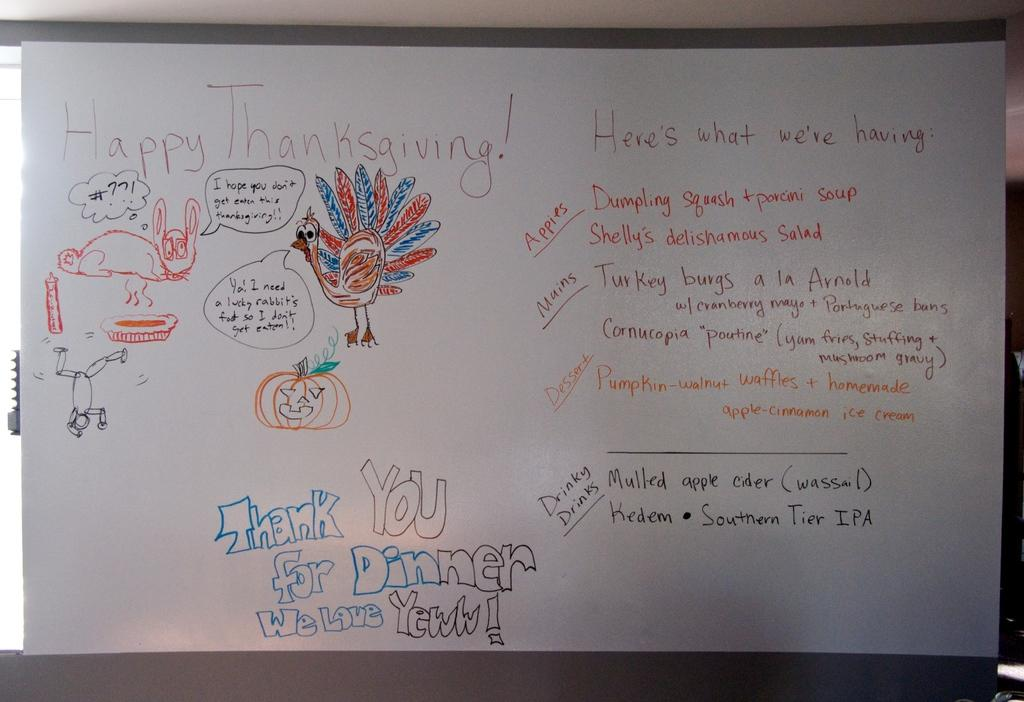What is the main object in the image? There is a white paper in the image. How is the white paper positioned or attached? The white paper is attached to a board. What can be found on the white paper? There is text and drawings on the white paper. How many babies are sitting on the seat in the image? There is no seat or babies present in the image. 